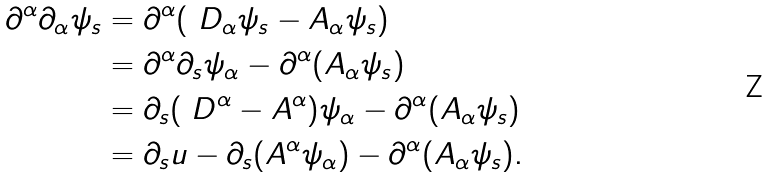<formula> <loc_0><loc_0><loc_500><loc_500>\partial ^ { \alpha } \partial _ { \alpha } \psi _ { s } & = \partial ^ { \alpha } ( \ D _ { \alpha } \psi _ { s } - A _ { \alpha } \psi _ { s } ) \\ & = \partial ^ { \alpha } \partial _ { s } \psi _ { \alpha } - \partial ^ { \alpha } ( A _ { \alpha } \psi _ { s } ) \\ & = \partial _ { s } ( \ D ^ { \alpha } - A ^ { \alpha } ) \psi _ { \alpha } - \partial ^ { \alpha } ( A _ { \alpha } \psi _ { s } ) \\ & = \partial _ { s } u - \partial _ { s } ( A ^ { \alpha } \psi _ { \alpha } ) - \partial ^ { \alpha } ( A _ { \alpha } \psi _ { s } ) .</formula> 